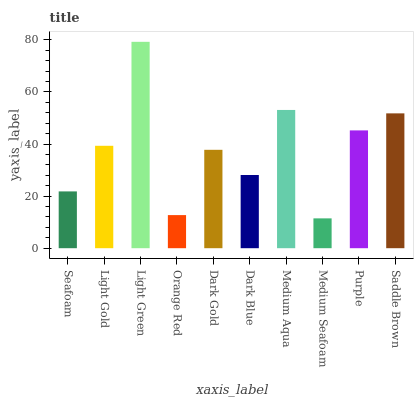Is Medium Seafoam the minimum?
Answer yes or no. Yes. Is Light Green the maximum?
Answer yes or no. Yes. Is Light Gold the minimum?
Answer yes or no. No. Is Light Gold the maximum?
Answer yes or no. No. Is Light Gold greater than Seafoam?
Answer yes or no. Yes. Is Seafoam less than Light Gold?
Answer yes or no. Yes. Is Seafoam greater than Light Gold?
Answer yes or no. No. Is Light Gold less than Seafoam?
Answer yes or no. No. Is Light Gold the high median?
Answer yes or no. Yes. Is Dark Gold the low median?
Answer yes or no. Yes. Is Saddle Brown the high median?
Answer yes or no. No. Is Purple the low median?
Answer yes or no. No. 